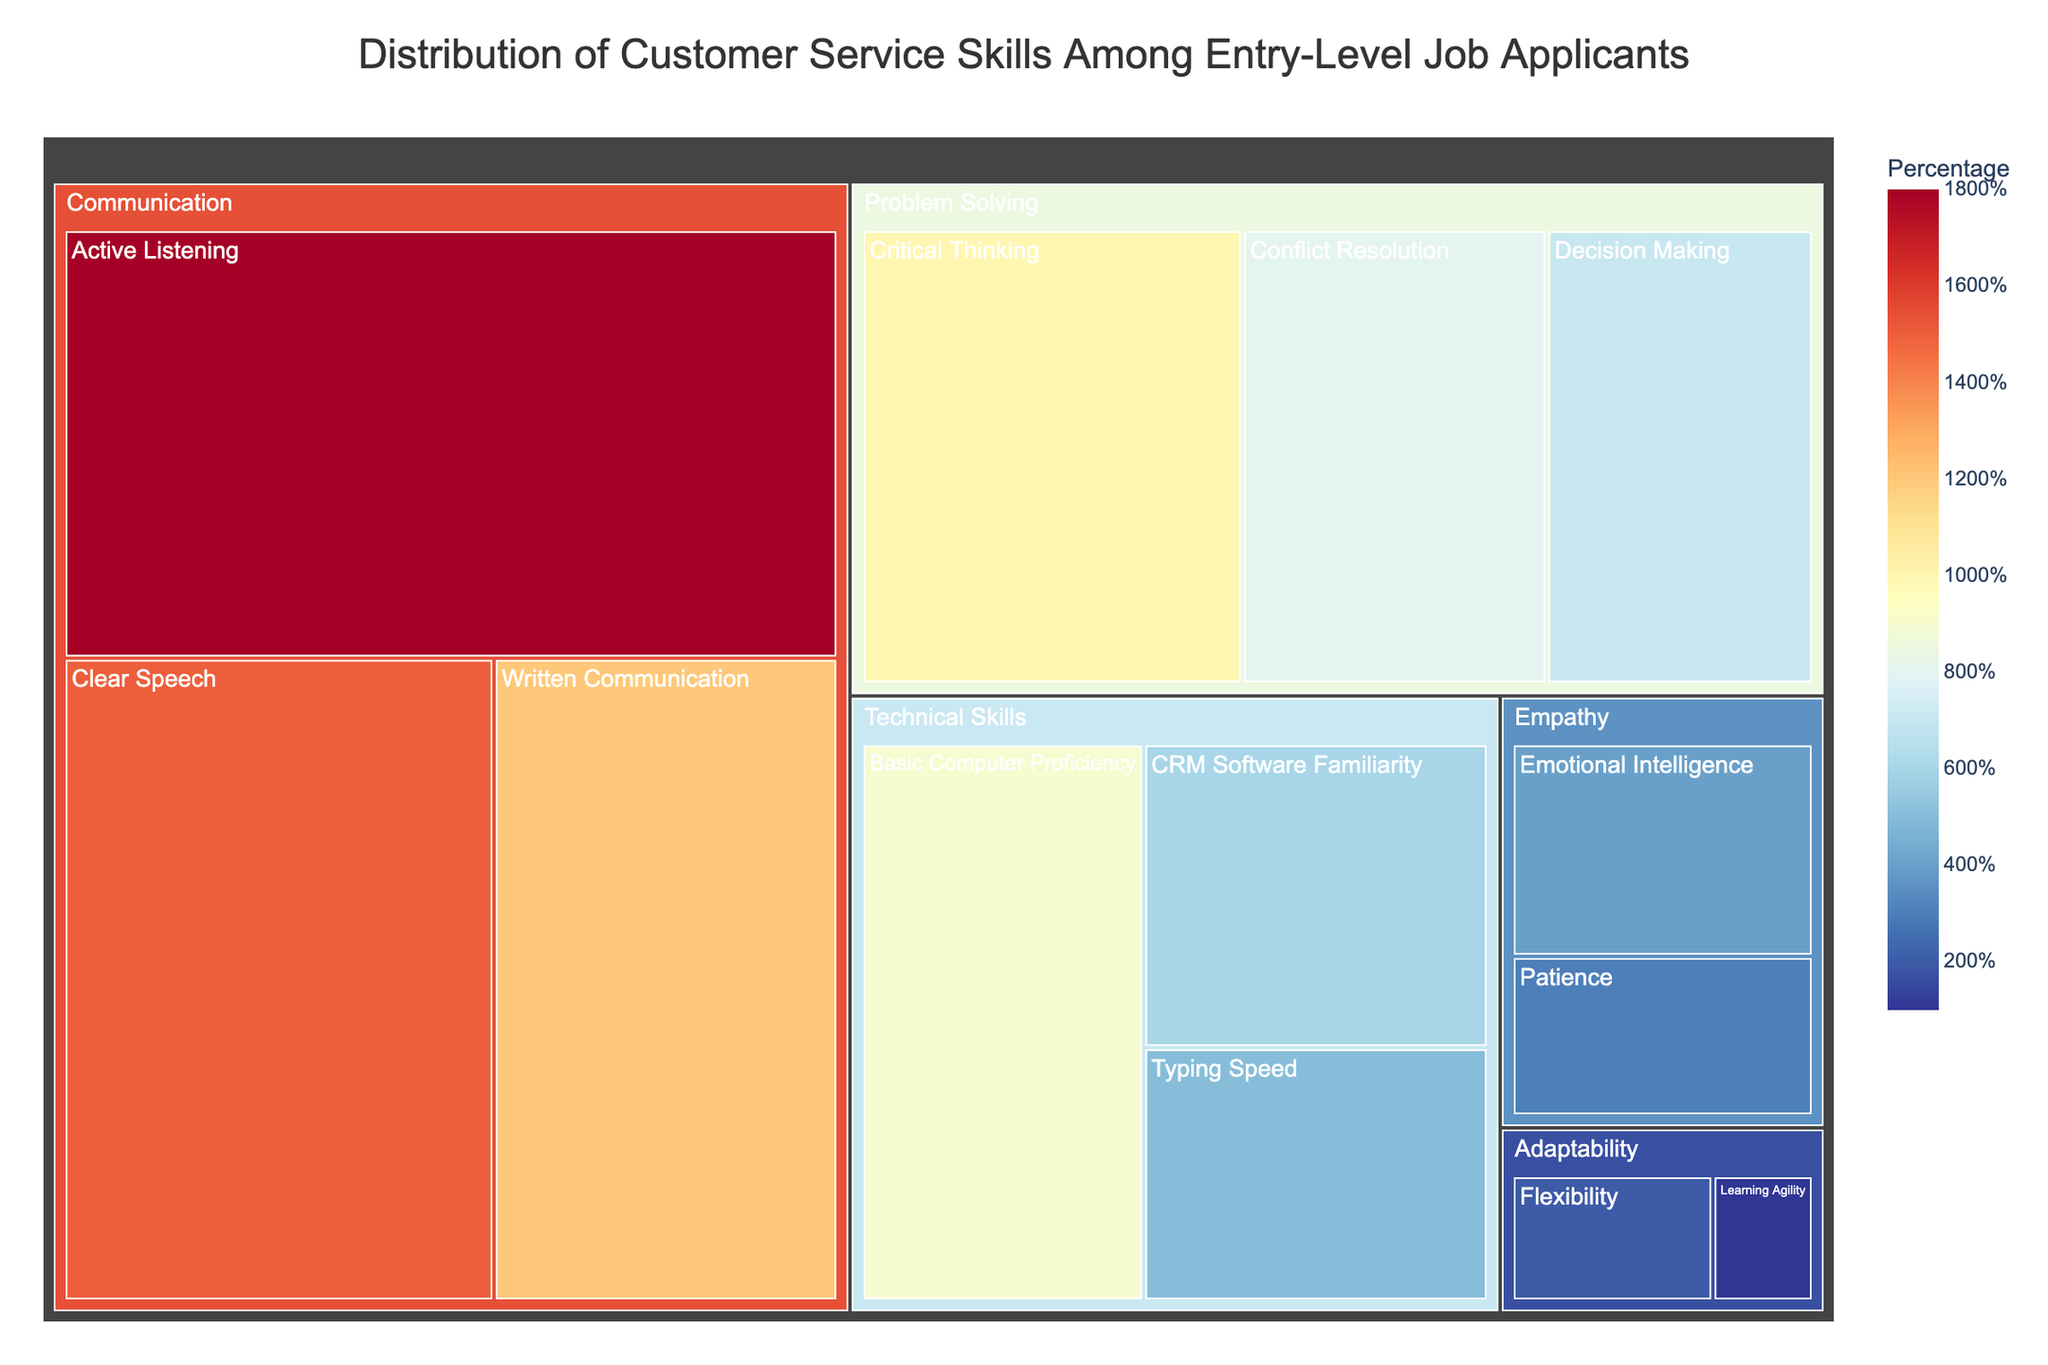What is the title of the treemap? The title is displayed at the top center of the treemap, providing an overview of what the figure represents.
Answer: Distribution of Customer Service Skills Among Entry-Level Job Applicants Which skill has the highest percentage? To determine this, look for the largest rectangle within the treemap, which typically indicates the highest percentage value assigned to a particular skill.
Answer: Active Listening What is the total percentage of skills under the "Communication" category? Sum the percentages of all skills within the "Communication" category: 18% (Active Listening) + 15% (Clear Speech) + 12% (Written Communication).
Answer: 45% Which category has the least percentage of the skill "Learning Agility"? Find the skill "Learning Agility" on the treemap and check the category it belongs to.
Answer: Adaptability Compare the percentage of "Basic Computer Proficiency" and "CRM Software Familiarity." Which one is higher and by how much? Locate both skills in the "Technical Skills" category, then subtract the smaller percentage from the larger one: 9% (Basic Computer Proficiency) - 6% (CRM Software Familiarity).
Answer: Basic Computer Proficiency is higher by 3% Under which category does the skill "Conflict Resolution" fall and what is its percentage? Find the skill "Conflict Resolution" on the treemap to see which category it belongs to and check its assigned percentage value.
Answer: Problem Solving, 8% What is the percentage difference between the skills "Patience" and "Decision Making"? Locate both skills on the treemap and subtract the smaller percentage from the larger one: 7% (Decision Making) - 3% (Patience).
Answer: Difference is 4% What is the average percentage of skills within the "Empathy" category? Add the percentages of all skills within the "Empathy" category and divide by the number of skills: (4% + 3%) / 2.
Answer: 3.5% What is the combined percentage of all skills under "Technical Skills"? Sum the percentages of all skills within the "Technical Skills" category: 9% (Basic Computer Proficiency) + 6% (CRM Software Familiarity) + 5% (Typing Speed).
Answer: 20% What is the smallest percentage value, and which skill does it belong to? Look for the smallest rectangle within the treemap to find the skill with the lowest percentage value.
Answer: Learning Agility, 1% 